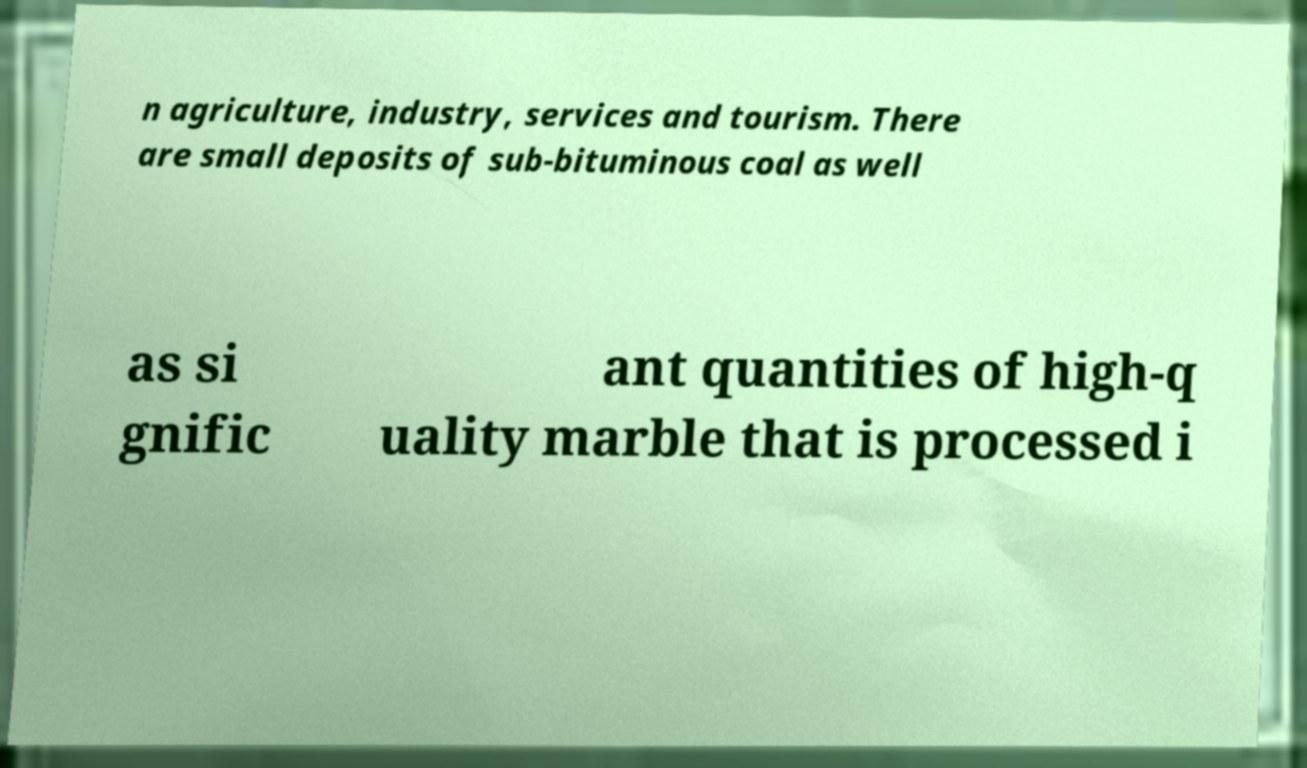Could you assist in decoding the text presented in this image and type it out clearly? n agriculture, industry, services and tourism. There are small deposits of sub-bituminous coal as well as si gnific ant quantities of high-q uality marble that is processed i 